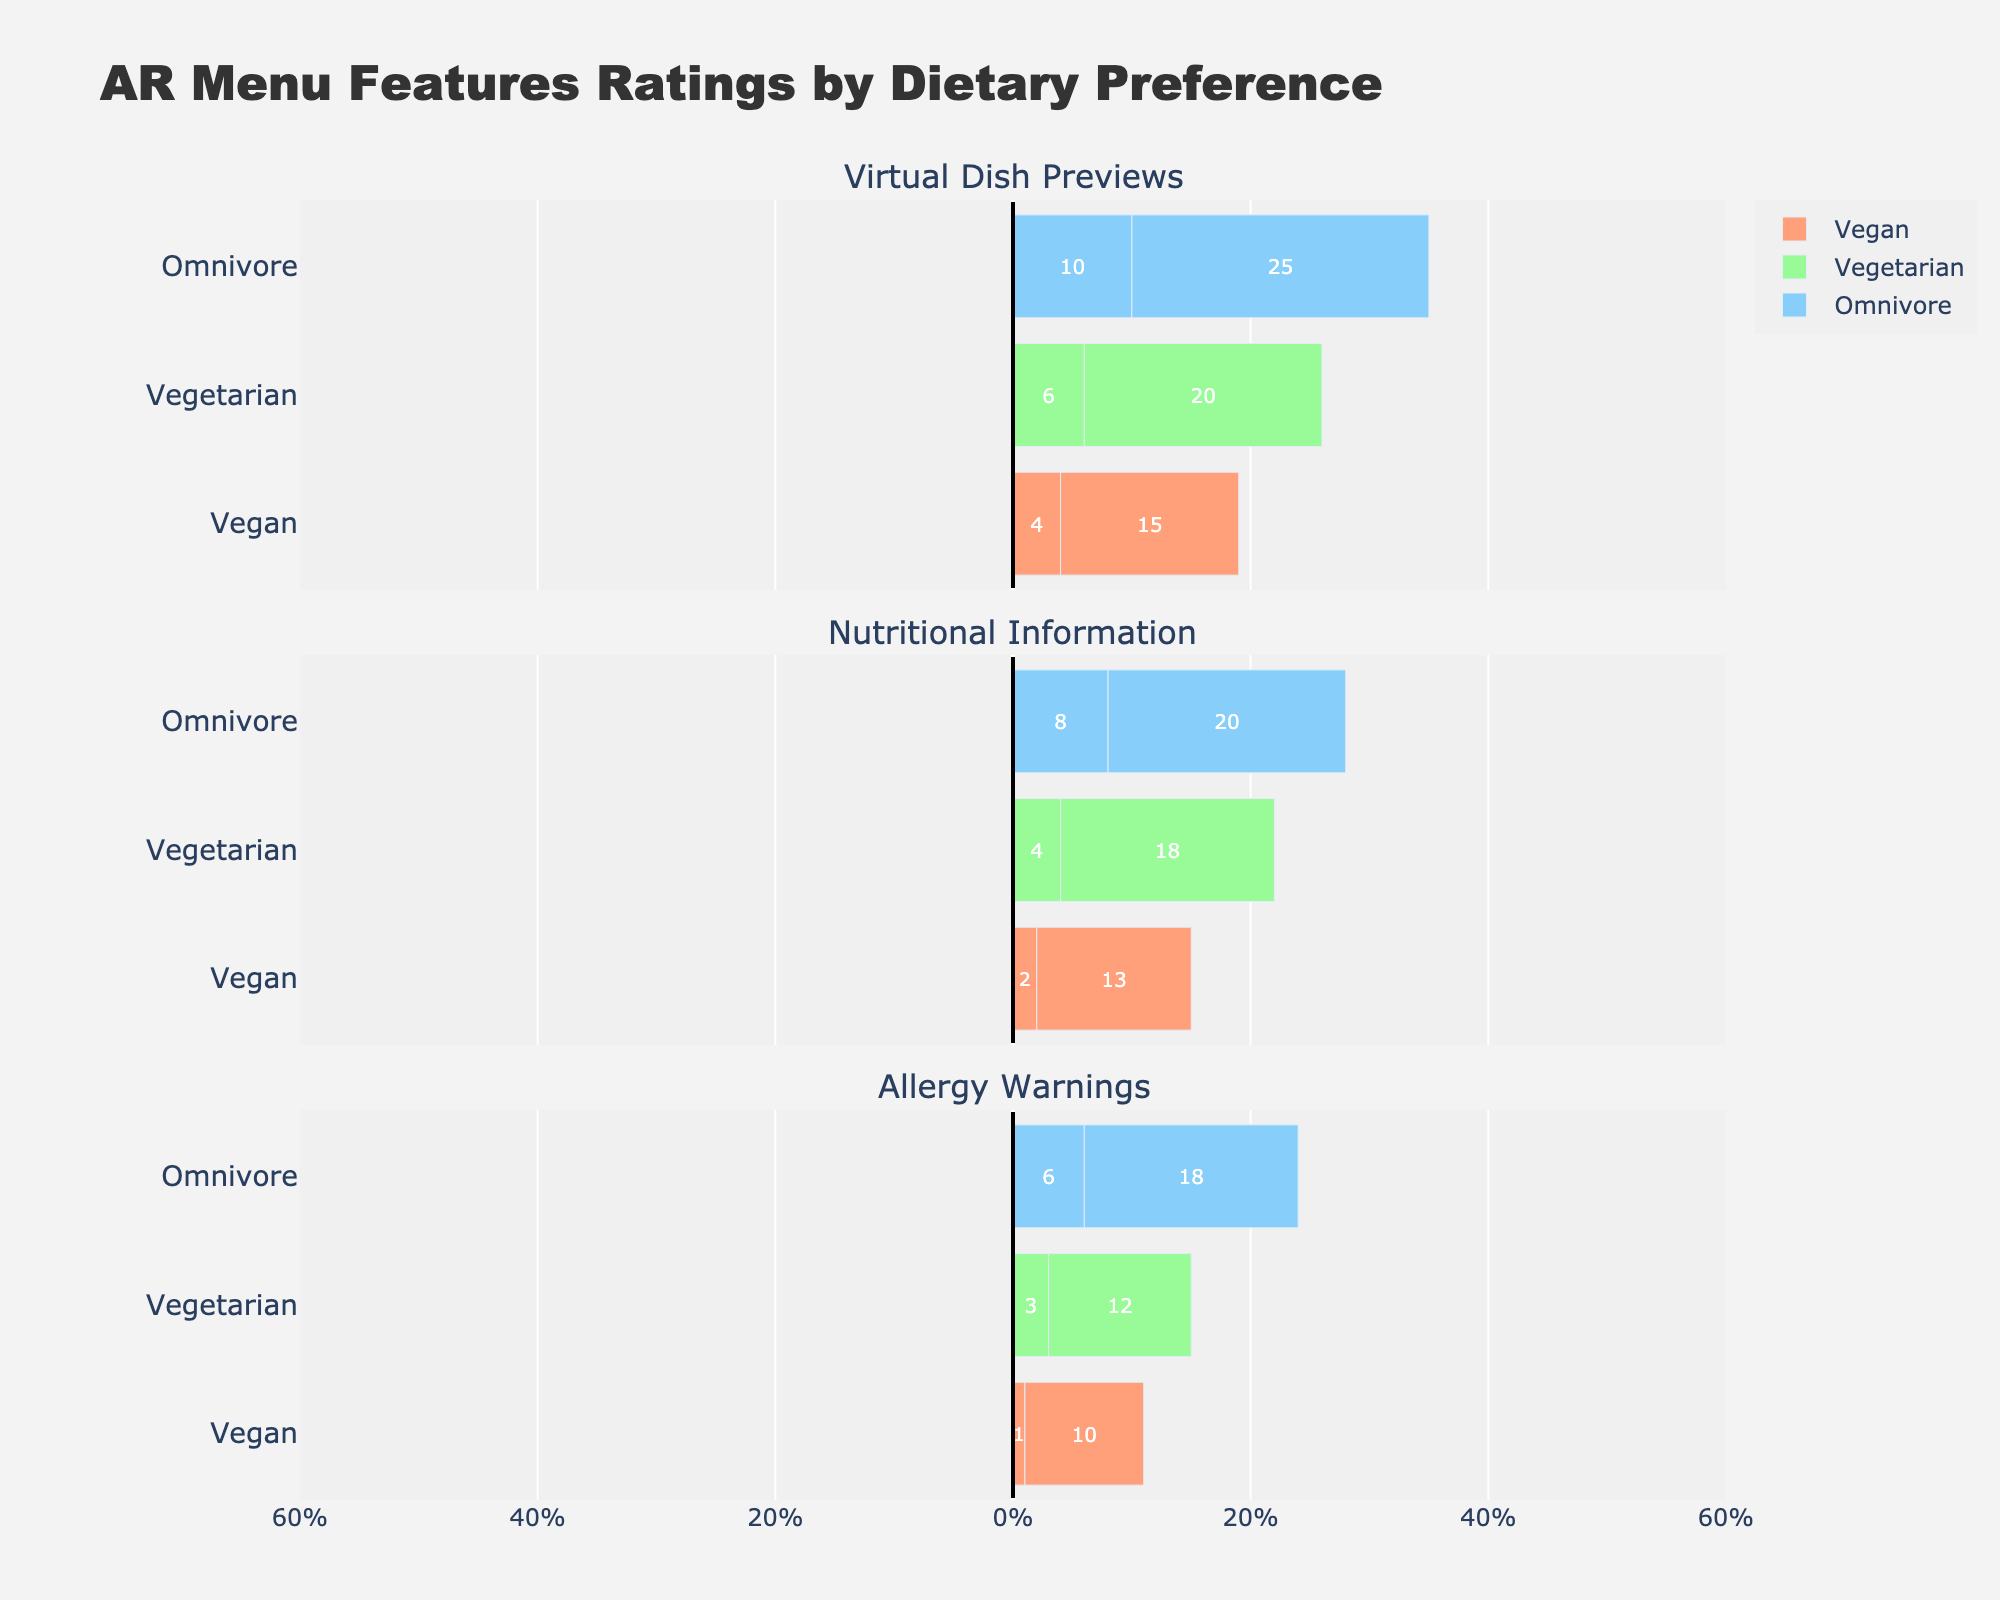Which dietary preference group is most positive about Allergy Warnings? The group with the highest combined ratings of "Like" and "Strongly Like" for Allergy Warnings will be the most positive. For the Vegan group, the sum is 38 + 51 = 89. For the Vegetarian group, it is 37 + 47 = 84, and for the Omnivore group, it is 34 + 39 = 73. So, the Vegan group is the most positive.
Answer: Vegan For Virtual Dish Previews, which group has the highest combined ratings of "Dislike" and "Strongly Dislike"? We need to add the "Dislike" and "Strongly Dislike" counts. For Vegans, it is 4 + 2 = 6. For Vegetarians, it is 6 + 3 = 9, and for Omnivores, it is 10 + 5 = 15. The Omnivore group has the highest combined ratings of "Dislike" and "Strongly Dislike".
Answer: Omnivore What is the range of Neutral ratings across all dietary preferences for Nutritional Information? To find the range, we need the difference between the maximum and minimum values of Neutral ratings. For Vegans, it is 13. For Vegetarians, it is 18. For Omnivores, it is 20. The range is 20 - 13 = 7.
Answer: 7 Which feature received the lowest total positive feedback ("Like" + "Strongly Like") from the Omnivore group? We need to sum the "Like" and "Strongly Like" counts for each feature. For Virtual Dish Previews, it's 30 + 30 = 60. For Nutritional Information, it's 35 + 33 = 68. For Allergy Warnings, it's 34 + 39 = 73. Virtual Dish Previews received the lowest positive feedback.
Answer: Virtual Dish Previews How do Vegan and Vegetarian groups compare in their ratings for Nutritional Information? By adding the "Like" and "Strongly Like" ratings for each group: Vegans have 50 + 34 = 84 positive ratings, and Vegetarians have 42 + 34 = 76 positive ratings. Vegans rated Nutritional Information more favorably than Vegetarians.
Answer: Vegans rated it more favorably For the feature Allergy Warnings, which dietary preference group gave the highest 'Neutral' rating? The Neutral ratings for Allergy Warnings are 10 for Vegans, 12 for Vegetarians, and 18 for Omnivores. Therefore, the Omnivore group gave the highest Neutral rating.
Answer: Omnivore 